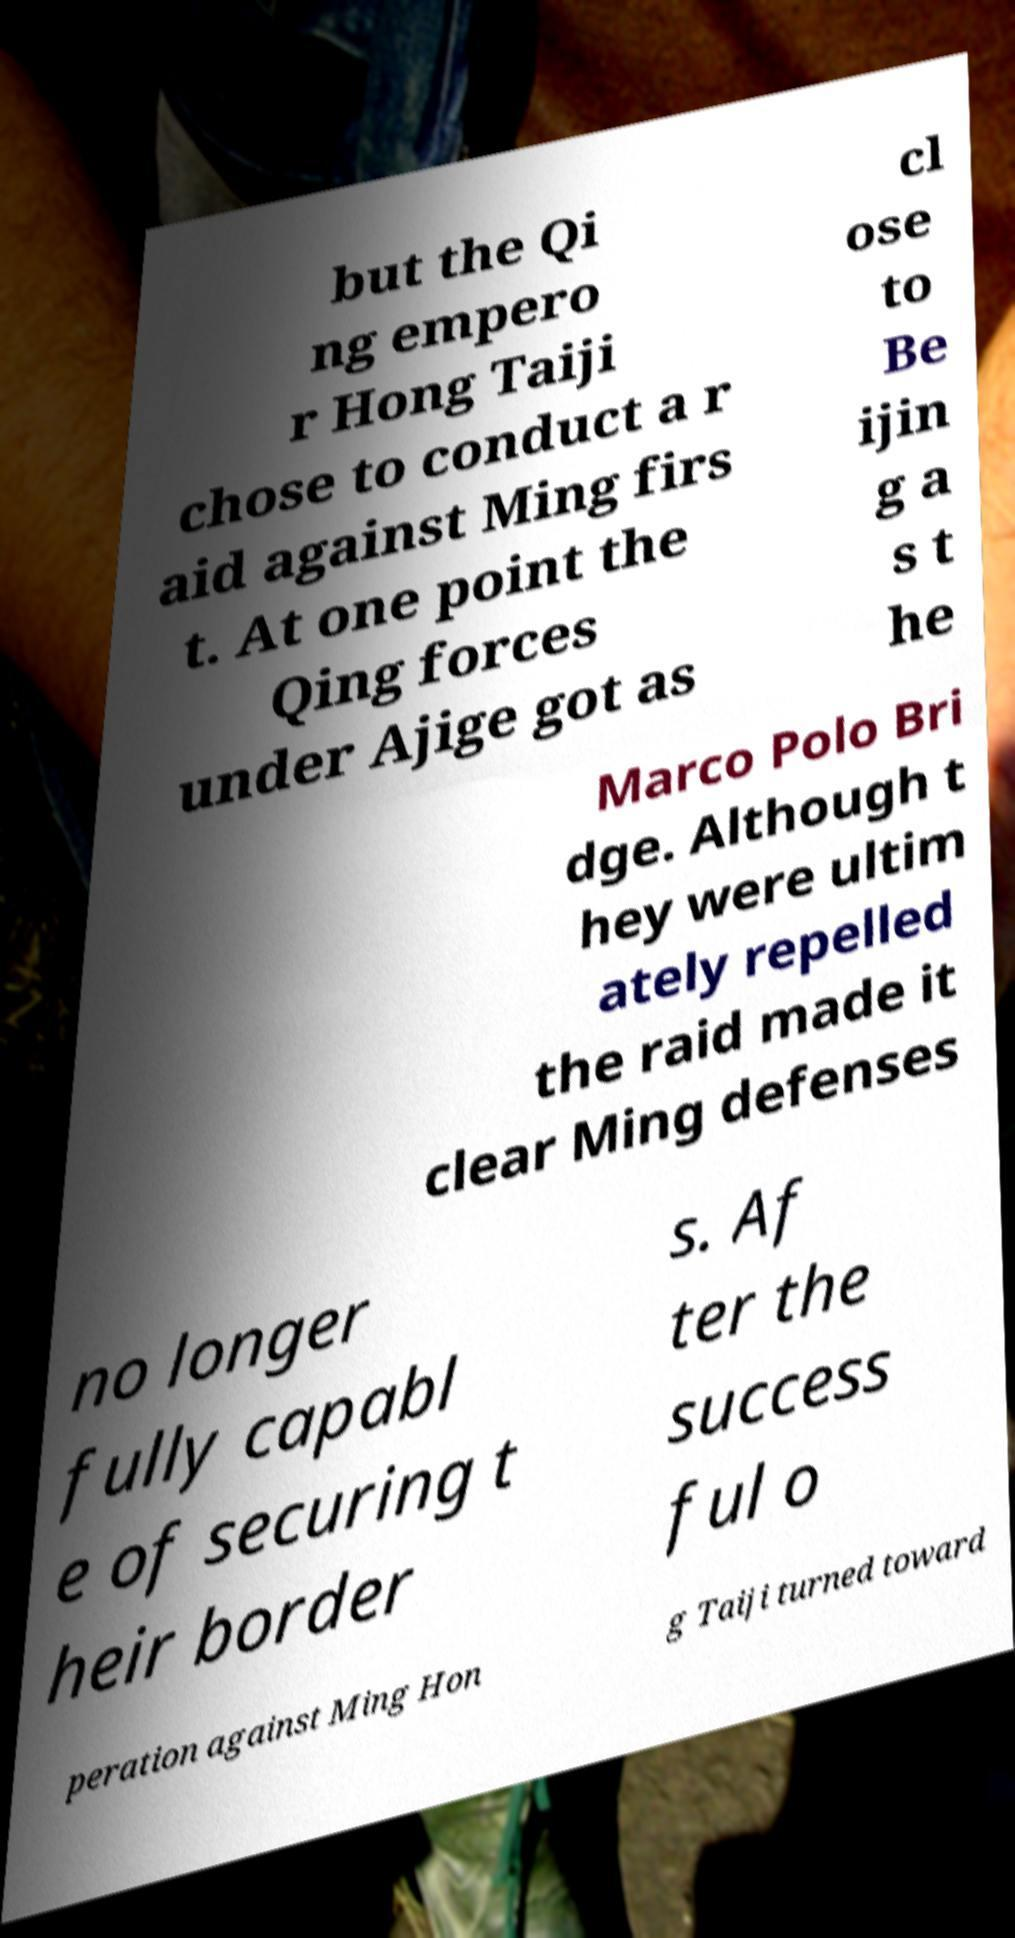There's text embedded in this image that I need extracted. Can you transcribe it verbatim? but the Qi ng empero r Hong Taiji chose to conduct a r aid against Ming firs t. At one point the Qing forces under Ajige got as cl ose to Be ijin g a s t he Marco Polo Bri dge. Although t hey were ultim ately repelled the raid made it clear Ming defenses no longer fully capabl e of securing t heir border s. Af ter the success ful o peration against Ming Hon g Taiji turned toward 